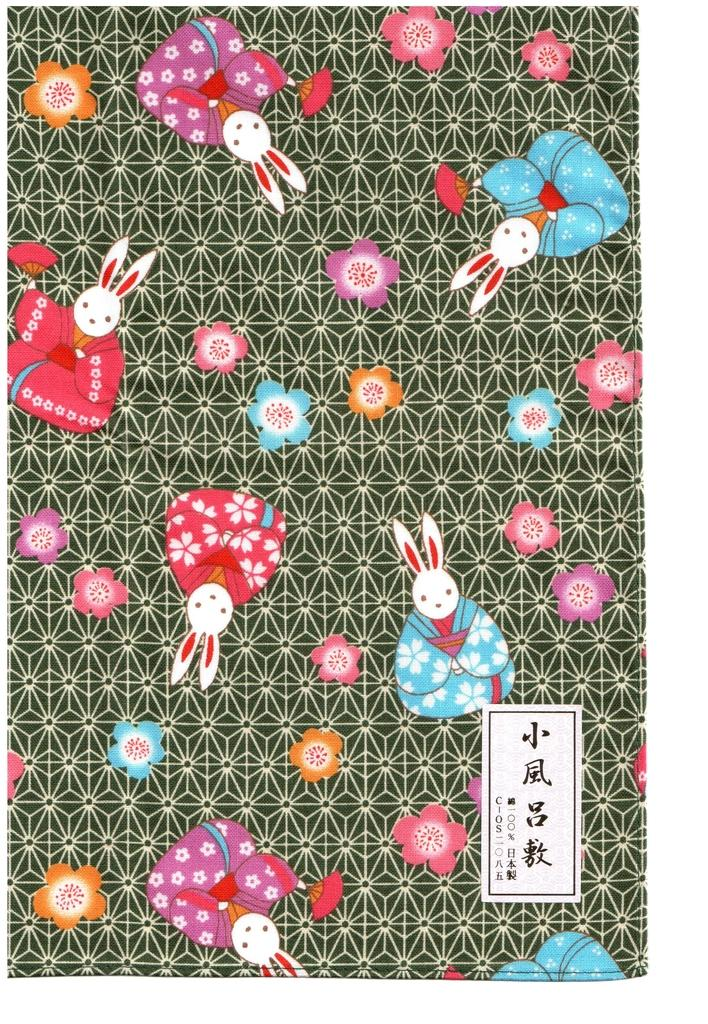What type of animals are depicted in the picture? There are rabbit images in the picture. What other elements can be seen in the picture besides the rabbits? There are colorful flowers in the picture. How would you describe the background of the image? The background of the image is black with a design. Where is the logo located in the image? The logo is on the right side of the image. What type of plastic material is used to make the flowers in the image? There is no plastic material used to make the flowers in the image; they are depicted as colorful images. 